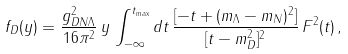Convert formula to latex. <formula><loc_0><loc_0><loc_500><loc_500>f _ { D } ( y ) = \frac { g ^ { 2 } _ { D N \Lambda } } { 1 6 \pi ^ { 2 } } \, y \, \int _ { - \infty } ^ { t _ { \max } } d t \, \frac { [ - t + ( m _ { \Lambda } - m _ { N } ) ^ { 2 } ] } { [ t - m _ { D } ^ { 2 } ] ^ { 2 } } \, F ^ { 2 } ( t ) \, ,</formula> 